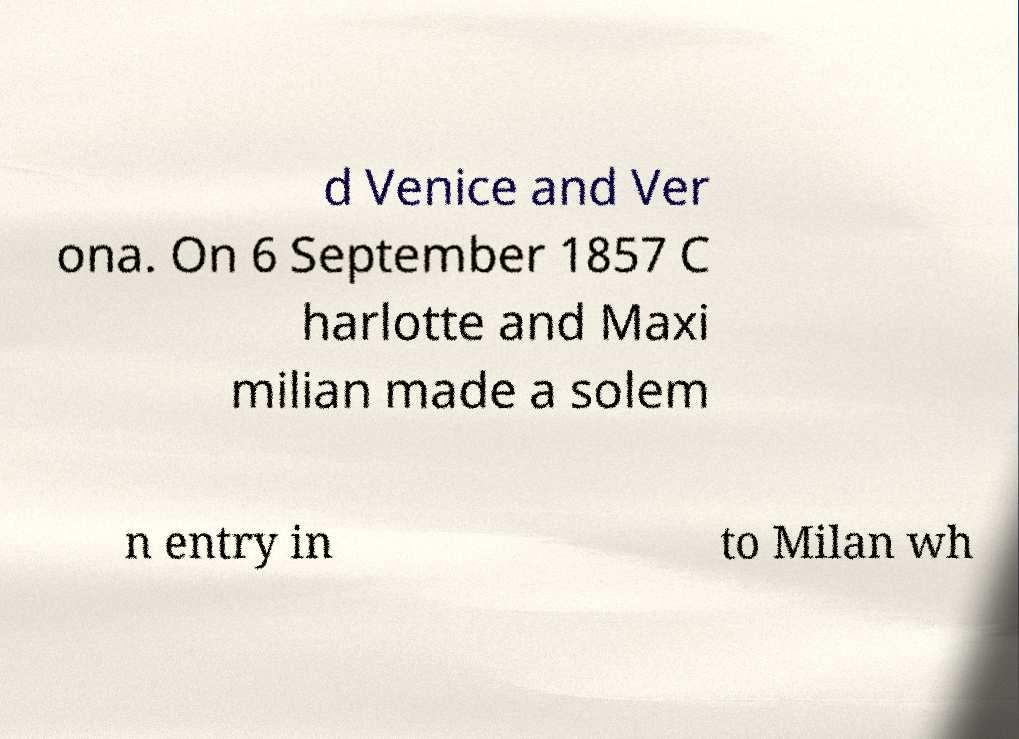What messages or text are displayed in this image? I need them in a readable, typed format. d Venice and Ver ona. On 6 September 1857 C harlotte and Maxi milian made a solem n entry in to Milan wh 